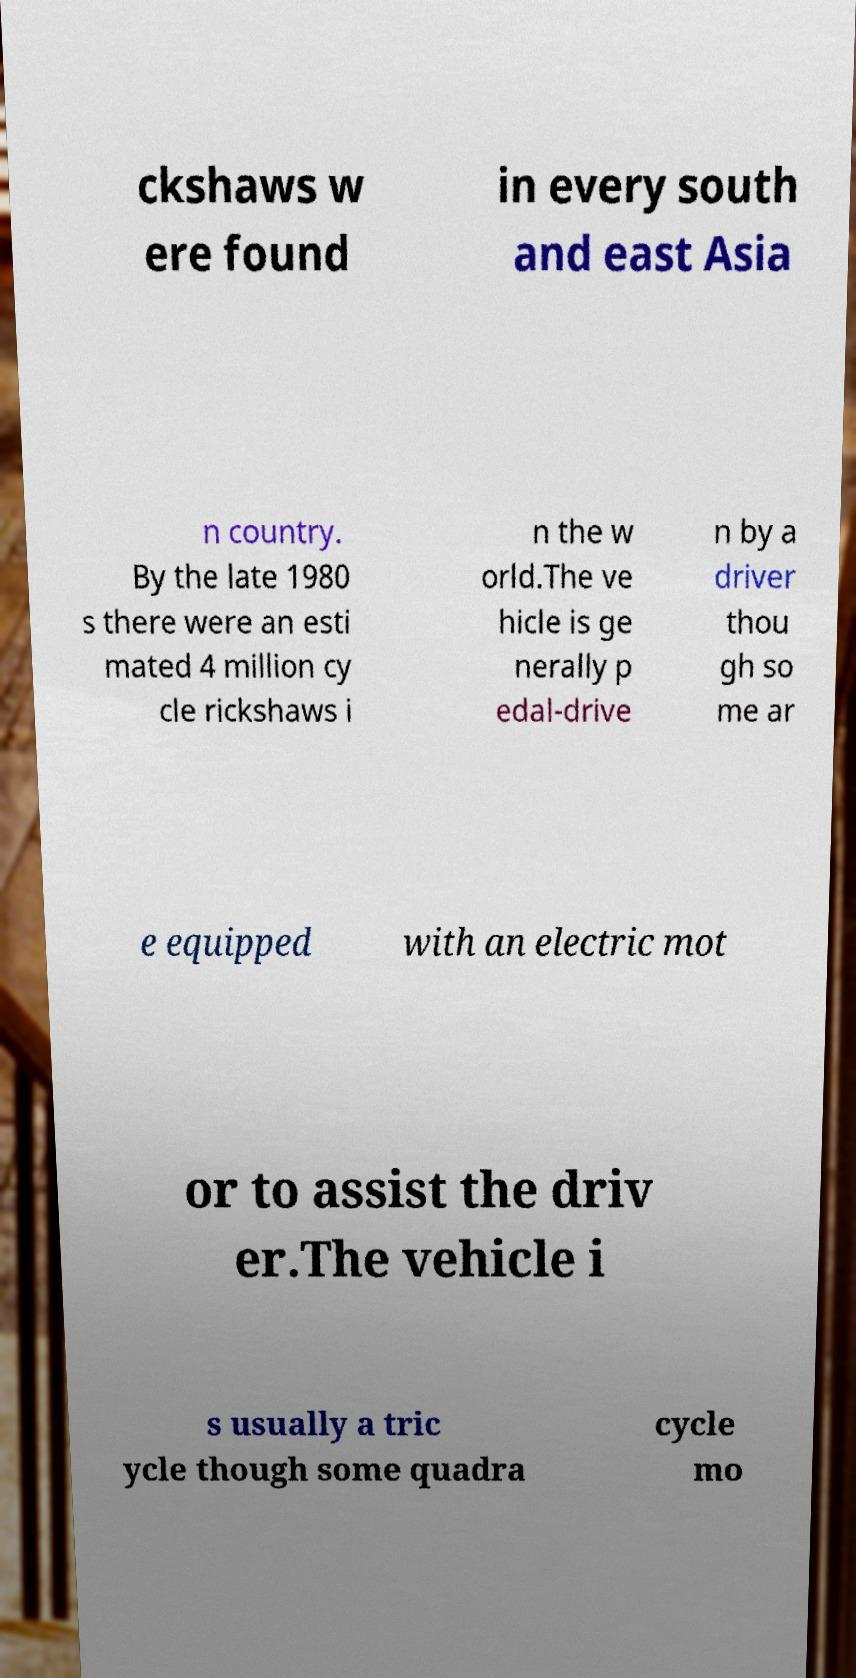I need the written content from this picture converted into text. Can you do that? ckshaws w ere found in every south and east Asia n country. By the late 1980 s there were an esti mated 4 million cy cle rickshaws i n the w orld.The ve hicle is ge nerally p edal-drive n by a driver thou gh so me ar e equipped with an electric mot or to assist the driv er.The vehicle i s usually a tric ycle though some quadra cycle mo 